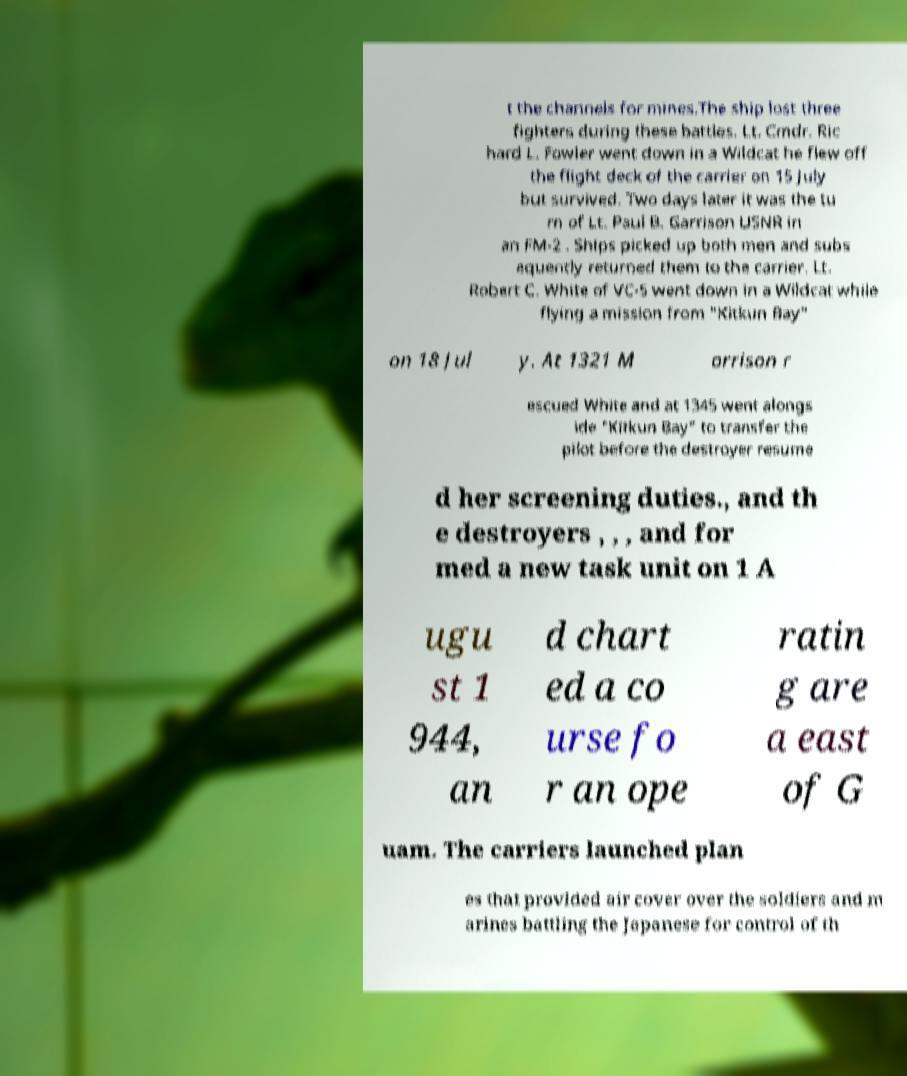Please identify and transcribe the text found in this image. t the channels for mines.The ship lost three fighters during these battles. Lt. Cmdr. Ric hard L. Fowler went down in a Wildcat he flew off the flight deck of the carrier on 15 July but survived. Two days later it was the tu rn of Lt. Paul B. Garrison USNR in an FM-2 . Ships picked up both men and subs equently returned them to the carrier. Lt. Robert C. White of VC-5 went down in a Wildcat while flying a mission from "Kitkun Bay" on 18 Jul y. At 1321 M orrison r escued White and at 1345 went alongs ide "Kitkun Bay" to transfer the pilot before the destroyer resume d her screening duties., and th e destroyers , , , and for med a new task unit on 1 A ugu st 1 944, an d chart ed a co urse fo r an ope ratin g are a east of G uam. The carriers launched plan es that provided air cover over the soldiers and m arines battling the Japanese for control of th 